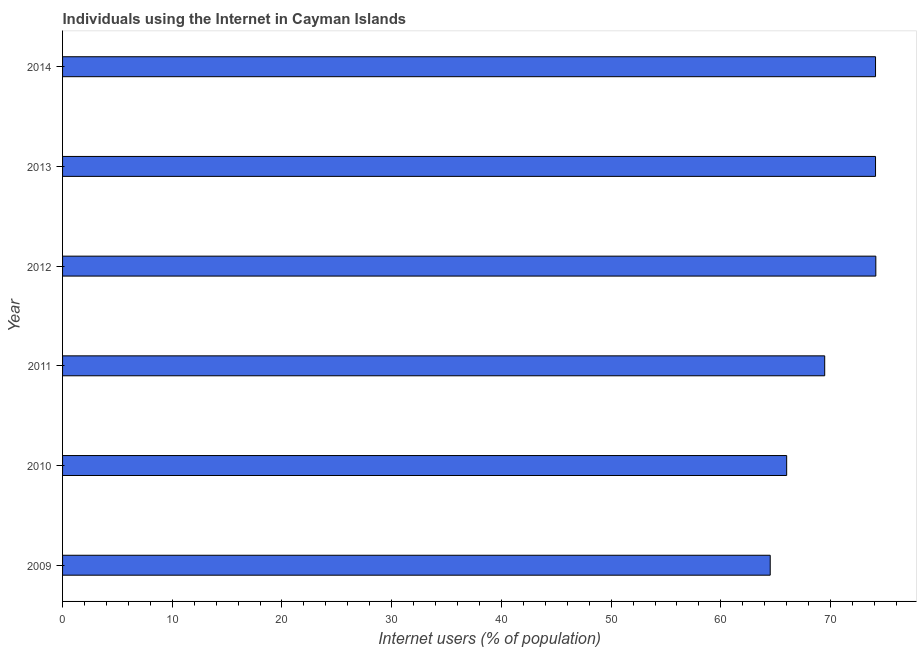Does the graph contain grids?
Provide a short and direct response. No. What is the title of the graph?
Your answer should be very brief. Individuals using the Internet in Cayman Islands. What is the label or title of the X-axis?
Offer a terse response. Internet users (% of population). What is the label or title of the Y-axis?
Your answer should be very brief. Year. What is the number of internet users in 2009?
Make the answer very short. 64.5. Across all years, what is the maximum number of internet users?
Provide a succinct answer. 74.13. Across all years, what is the minimum number of internet users?
Your answer should be very brief. 64.5. In which year was the number of internet users minimum?
Your response must be concise. 2009. What is the sum of the number of internet users?
Ensure brevity in your answer.  422.29. What is the average number of internet users per year?
Provide a succinct answer. 70.38. What is the median number of internet users?
Provide a succinct answer. 71.78. In how many years, is the number of internet users greater than 52 %?
Make the answer very short. 6. Do a majority of the years between 2009 and 2011 (inclusive) have number of internet users greater than 50 %?
Provide a short and direct response. Yes. What is the ratio of the number of internet users in 2010 to that in 2013?
Provide a succinct answer. 0.89. What is the difference between the highest and the second highest number of internet users?
Keep it short and to the point. 0.03. Is the sum of the number of internet users in 2010 and 2012 greater than the maximum number of internet users across all years?
Offer a very short reply. Yes. What is the difference between the highest and the lowest number of internet users?
Make the answer very short. 9.63. How many years are there in the graph?
Your answer should be compact. 6. What is the Internet users (% of population) of 2009?
Your answer should be very brief. 64.5. What is the Internet users (% of population) in 2010?
Give a very brief answer. 66. What is the Internet users (% of population) in 2011?
Provide a succinct answer. 69.47. What is the Internet users (% of population) in 2012?
Offer a terse response. 74.13. What is the Internet users (% of population) of 2013?
Offer a terse response. 74.1. What is the Internet users (% of population) in 2014?
Keep it short and to the point. 74.1. What is the difference between the Internet users (% of population) in 2009 and 2010?
Keep it short and to the point. -1.5. What is the difference between the Internet users (% of population) in 2009 and 2011?
Offer a very short reply. -4.97. What is the difference between the Internet users (% of population) in 2009 and 2012?
Give a very brief answer. -9.63. What is the difference between the Internet users (% of population) in 2009 and 2014?
Your answer should be compact. -9.6. What is the difference between the Internet users (% of population) in 2010 and 2011?
Keep it short and to the point. -3.47. What is the difference between the Internet users (% of population) in 2010 and 2012?
Your answer should be compact. -8.13. What is the difference between the Internet users (% of population) in 2010 and 2013?
Ensure brevity in your answer.  -8.1. What is the difference between the Internet users (% of population) in 2011 and 2012?
Keep it short and to the point. -4.66. What is the difference between the Internet users (% of population) in 2011 and 2013?
Offer a very short reply. -4.63. What is the difference between the Internet users (% of population) in 2011 and 2014?
Offer a very short reply. -4.63. What is the difference between the Internet users (% of population) in 2012 and 2013?
Make the answer very short. 0.03. What is the difference between the Internet users (% of population) in 2012 and 2014?
Keep it short and to the point. 0.03. What is the difference between the Internet users (% of population) in 2013 and 2014?
Ensure brevity in your answer.  0. What is the ratio of the Internet users (% of population) in 2009 to that in 2011?
Ensure brevity in your answer.  0.93. What is the ratio of the Internet users (% of population) in 2009 to that in 2012?
Give a very brief answer. 0.87. What is the ratio of the Internet users (% of population) in 2009 to that in 2013?
Your answer should be compact. 0.87. What is the ratio of the Internet users (% of population) in 2009 to that in 2014?
Make the answer very short. 0.87. What is the ratio of the Internet users (% of population) in 2010 to that in 2012?
Provide a short and direct response. 0.89. What is the ratio of the Internet users (% of population) in 2010 to that in 2013?
Keep it short and to the point. 0.89. What is the ratio of the Internet users (% of population) in 2010 to that in 2014?
Ensure brevity in your answer.  0.89. What is the ratio of the Internet users (% of population) in 2011 to that in 2012?
Give a very brief answer. 0.94. What is the ratio of the Internet users (% of population) in 2011 to that in 2013?
Offer a very short reply. 0.94. What is the ratio of the Internet users (% of population) in 2011 to that in 2014?
Ensure brevity in your answer.  0.94. What is the ratio of the Internet users (% of population) in 2012 to that in 2013?
Your answer should be compact. 1. What is the ratio of the Internet users (% of population) in 2012 to that in 2014?
Your answer should be compact. 1. What is the ratio of the Internet users (% of population) in 2013 to that in 2014?
Your response must be concise. 1. 